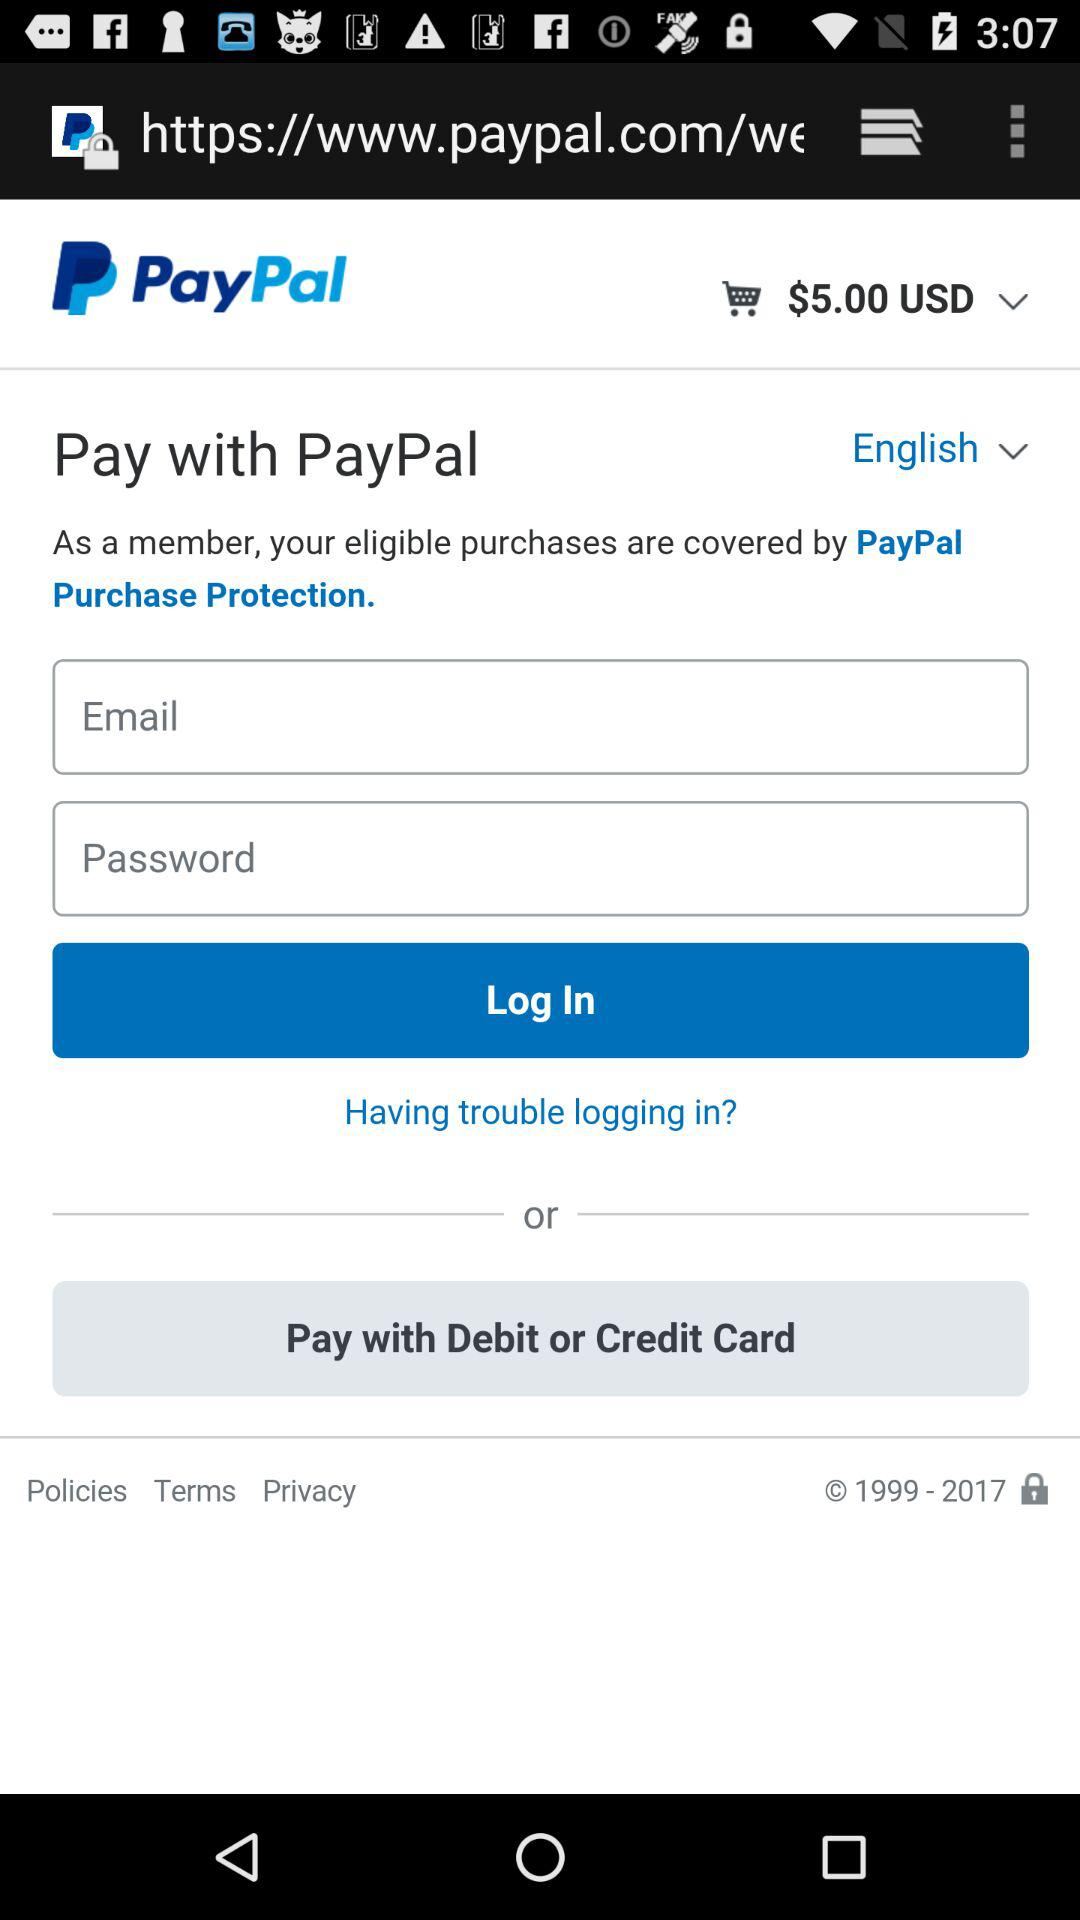What is the application name? The application name is "PayPal". 